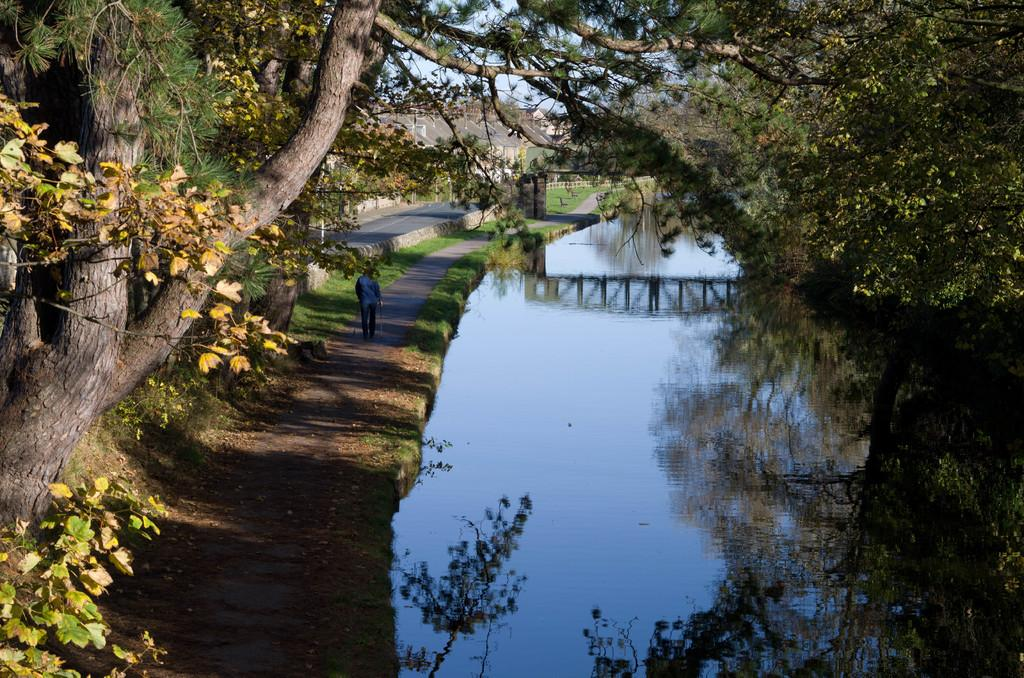What is the primary element in the image? The image consists of water. Can you describe the person in the image? There is a person walking on the left side of the image. What type of vegetation is present in the image? Trees are present on both the left and right sides of the image. What structures can be seen in the background of the image? There are houses visible in the background of the image. What is the fireman doing after his shift in the image? There is no fireman present in the image, and therefore no such activity can be observed. 